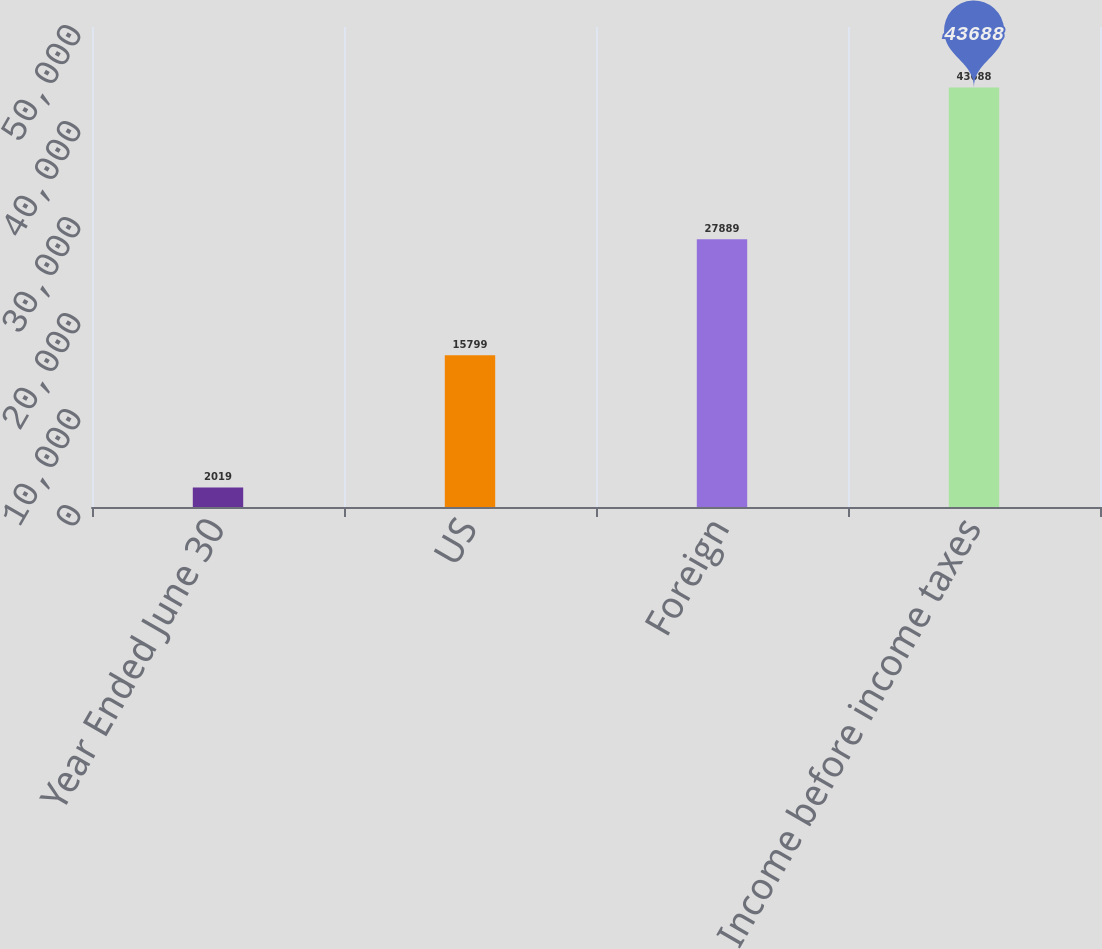<chart> <loc_0><loc_0><loc_500><loc_500><bar_chart><fcel>Year Ended June 30<fcel>US<fcel>Foreign<fcel>Income before income taxes<nl><fcel>2019<fcel>15799<fcel>27889<fcel>43688<nl></chart> 